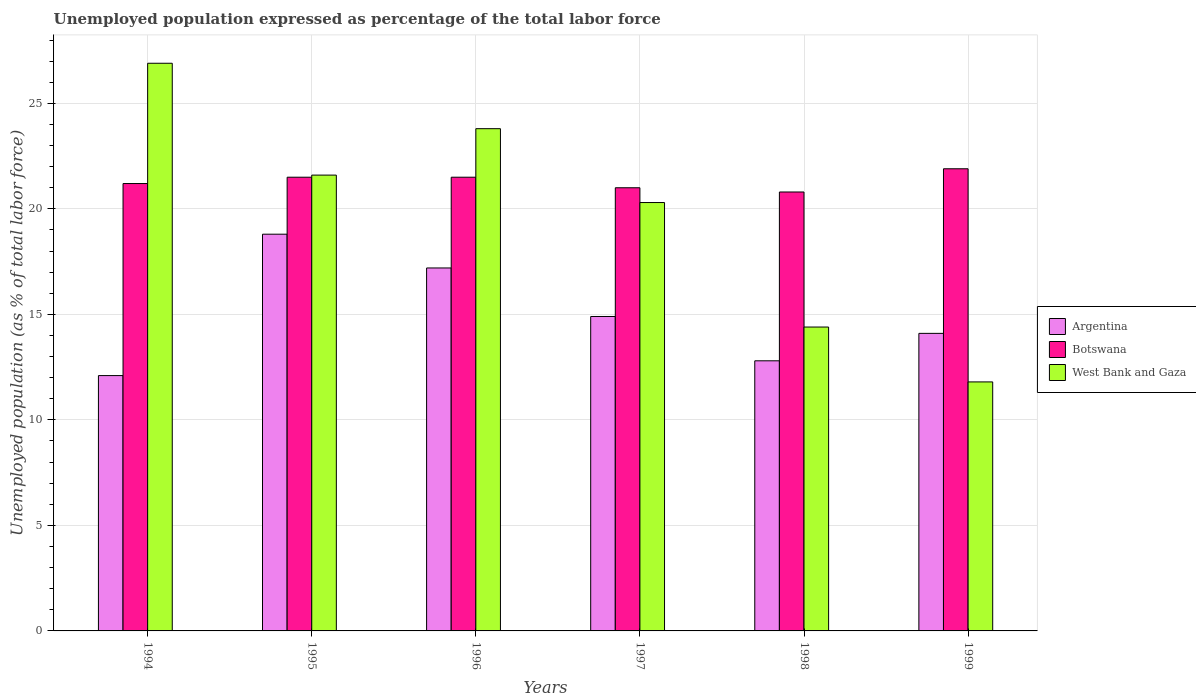How many different coloured bars are there?
Ensure brevity in your answer.  3. Are the number of bars per tick equal to the number of legend labels?
Make the answer very short. Yes. Are the number of bars on each tick of the X-axis equal?
Your answer should be very brief. Yes. How many bars are there on the 1st tick from the right?
Make the answer very short. 3. In how many cases, is the number of bars for a given year not equal to the number of legend labels?
Offer a very short reply. 0. What is the unemployment in in Argentina in 1996?
Your response must be concise. 17.2. Across all years, what is the maximum unemployment in in Botswana?
Make the answer very short. 21.9. Across all years, what is the minimum unemployment in in Botswana?
Offer a very short reply. 20.8. In which year was the unemployment in in Argentina maximum?
Make the answer very short. 1995. What is the total unemployment in in West Bank and Gaza in the graph?
Offer a terse response. 118.8. What is the difference between the unemployment in in Botswana in 1997 and the unemployment in in Argentina in 1994?
Provide a succinct answer. 8.9. What is the average unemployment in in West Bank and Gaza per year?
Keep it short and to the point. 19.8. In the year 1998, what is the difference between the unemployment in in West Bank and Gaza and unemployment in in Argentina?
Your answer should be very brief. 1.6. What is the ratio of the unemployment in in West Bank and Gaza in 1994 to that in 1996?
Make the answer very short. 1.13. What is the difference between the highest and the second highest unemployment in in Botswana?
Offer a terse response. 0.4. What is the difference between the highest and the lowest unemployment in in Argentina?
Your response must be concise. 6.7. In how many years, is the unemployment in in West Bank and Gaza greater than the average unemployment in in West Bank and Gaza taken over all years?
Your answer should be compact. 4. What does the 2nd bar from the left in 1995 represents?
Your answer should be very brief. Botswana. What does the 3rd bar from the right in 1996 represents?
Offer a terse response. Argentina. Is it the case that in every year, the sum of the unemployment in in West Bank and Gaza and unemployment in in Botswana is greater than the unemployment in in Argentina?
Make the answer very short. Yes. How many years are there in the graph?
Offer a terse response. 6. Does the graph contain any zero values?
Ensure brevity in your answer.  No. How many legend labels are there?
Keep it short and to the point. 3. What is the title of the graph?
Offer a very short reply. Unemployed population expressed as percentage of the total labor force. What is the label or title of the X-axis?
Your answer should be compact. Years. What is the label or title of the Y-axis?
Offer a terse response. Unemployed population (as % of total labor force). What is the Unemployed population (as % of total labor force) in Argentina in 1994?
Give a very brief answer. 12.1. What is the Unemployed population (as % of total labor force) in Botswana in 1994?
Your answer should be compact. 21.2. What is the Unemployed population (as % of total labor force) of West Bank and Gaza in 1994?
Make the answer very short. 26.9. What is the Unemployed population (as % of total labor force) in Argentina in 1995?
Provide a short and direct response. 18.8. What is the Unemployed population (as % of total labor force) in West Bank and Gaza in 1995?
Provide a short and direct response. 21.6. What is the Unemployed population (as % of total labor force) of Argentina in 1996?
Your response must be concise. 17.2. What is the Unemployed population (as % of total labor force) in Botswana in 1996?
Your response must be concise. 21.5. What is the Unemployed population (as % of total labor force) of West Bank and Gaza in 1996?
Provide a succinct answer. 23.8. What is the Unemployed population (as % of total labor force) in Argentina in 1997?
Make the answer very short. 14.9. What is the Unemployed population (as % of total labor force) in West Bank and Gaza in 1997?
Make the answer very short. 20.3. What is the Unemployed population (as % of total labor force) in Argentina in 1998?
Offer a very short reply. 12.8. What is the Unemployed population (as % of total labor force) of Botswana in 1998?
Your response must be concise. 20.8. What is the Unemployed population (as % of total labor force) in West Bank and Gaza in 1998?
Keep it short and to the point. 14.4. What is the Unemployed population (as % of total labor force) of Argentina in 1999?
Give a very brief answer. 14.1. What is the Unemployed population (as % of total labor force) in Botswana in 1999?
Provide a succinct answer. 21.9. What is the Unemployed population (as % of total labor force) in West Bank and Gaza in 1999?
Offer a terse response. 11.8. Across all years, what is the maximum Unemployed population (as % of total labor force) of Argentina?
Provide a short and direct response. 18.8. Across all years, what is the maximum Unemployed population (as % of total labor force) of Botswana?
Provide a succinct answer. 21.9. Across all years, what is the maximum Unemployed population (as % of total labor force) in West Bank and Gaza?
Your answer should be very brief. 26.9. Across all years, what is the minimum Unemployed population (as % of total labor force) of Argentina?
Offer a very short reply. 12.1. Across all years, what is the minimum Unemployed population (as % of total labor force) in Botswana?
Your answer should be compact. 20.8. Across all years, what is the minimum Unemployed population (as % of total labor force) of West Bank and Gaza?
Ensure brevity in your answer.  11.8. What is the total Unemployed population (as % of total labor force) of Argentina in the graph?
Your answer should be compact. 89.9. What is the total Unemployed population (as % of total labor force) of Botswana in the graph?
Provide a succinct answer. 127.9. What is the total Unemployed population (as % of total labor force) in West Bank and Gaza in the graph?
Ensure brevity in your answer.  118.8. What is the difference between the Unemployed population (as % of total labor force) of Argentina in 1994 and that in 1997?
Keep it short and to the point. -2.8. What is the difference between the Unemployed population (as % of total labor force) in Botswana in 1994 and that in 1997?
Ensure brevity in your answer.  0.2. What is the difference between the Unemployed population (as % of total labor force) of Argentina in 1994 and that in 1998?
Keep it short and to the point. -0.7. What is the difference between the Unemployed population (as % of total labor force) in Botswana in 1994 and that in 1999?
Give a very brief answer. -0.7. What is the difference between the Unemployed population (as % of total labor force) in West Bank and Gaza in 1994 and that in 1999?
Keep it short and to the point. 15.1. What is the difference between the Unemployed population (as % of total labor force) in Argentina in 1995 and that in 1996?
Provide a succinct answer. 1.6. What is the difference between the Unemployed population (as % of total labor force) of West Bank and Gaza in 1995 and that in 1996?
Your answer should be compact. -2.2. What is the difference between the Unemployed population (as % of total labor force) of Argentina in 1995 and that in 1997?
Give a very brief answer. 3.9. What is the difference between the Unemployed population (as % of total labor force) in Botswana in 1995 and that in 1997?
Provide a short and direct response. 0.5. What is the difference between the Unemployed population (as % of total labor force) in West Bank and Gaza in 1995 and that in 1997?
Offer a terse response. 1.3. What is the difference between the Unemployed population (as % of total labor force) in Argentina in 1995 and that in 1998?
Keep it short and to the point. 6. What is the difference between the Unemployed population (as % of total labor force) of Botswana in 1995 and that in 1998?
Your answer should be compact. 0.7. What is the difference between the Unemployed population (as % of total labor force) of West Bank and Gaza in 1995 and that in 1998?
Provide a short and direct response. 7.2. What is the difference between the Unemployed population (as % of total labor force) in West Bank and Gaza in 1995 and that in 1999?
Give a very brief answer. 9.8. What is the difference between the Unemployed population (as % of total labor force) in West Bank and Gaza in 1996 and that in 1997?
Offer a terse response. 3.5. What is the difference between the Unemployed population (as % of total labor force) of Argentina in 1996 and that in 1998?
Make the answer very short. 4.4. What is the difference between the Unemployed population (as % of total labor force) in Botswana in 1996 and that in 1998?
Your answer should be very brief. 0.7. What is the difference between the Unemployed population (as % of total labor force) in West Bank and Gaza in 1996 and that in 1998?
Your response must be concise. 9.4. What is the difference between the Unemployed population (as % of total labor force) in West Bank and Gaza in 1996 and that in 1999?
Make the answer very short. 12. What is the difference between the Unemployed population (as % of total labor force) in West Bank and Gaza in 1997 and that in 1998?
Offer a terse response. 5.9. What is the difference between the Unemployed population (as % of total labor force) of Argentina in 1997 and that in 1999?
Give a very brief answer. 0.8. What is the difference between the Unemployed population (as % of total labor force) in Botswana in 1997 and that in 1999?
Offer a terse response. -0.9. What is the difference between the Unemployed population (as % of total labor force) of West Bank and Gaza in 1998 and that in 1999?
Make the answer very short. 2.6. What is the difference between the Unemployed population (as % of total labor force) in Argentina in 1994 and the Unemployed population (as % of total labor force) in Botswana in 1995?
Provide a succinct answer. -9.4. What is the difference between the Unemployed population (as % of total labor force) of Botswana in 1994 and the Unemployed population (as % of total labor force) of West Bank and Gaza in 1995?
Provide a short and direct response. -0.4. What is the difference between the Unemployed population (as % of total labor force) of Argentina in 1994 and the Unemployed population (as % of total labor force) of West Bank and Gaza in 1996?
Your answer should be compact. -11.7. What is the difference between the Unemployed population (as % of total labor force) in Botswana in 1994 and the Unemployed population (as % of total labor force) in West Bank and Gaza in 1996?
Make the answer very short. -2.6. What is the difference between the Unemployed population (as % of total labor force) of Botswana in 1994 and the Unemployed population (as % of total labor force) of West Bank and Gaza in 1997?
Make the answer very short. 0.9. What is the difference between the Unemployed population (as % of total labor force) in Argentina in 1994 and the Unemployed population (as % of total labor force) in Botswana in 1998?
Ensure brevity in your answer.  -8.7. What is the difference between the Unemployed population (as % of total labor force) of Argentina in 1994 and the Unemployed population (as % of total labor force) of Botswana in 1999?
Your answer should be compact. -9.8. What is the difference between the Unemployed population (as % of total labor force) in Botswana in 1994 and the Unemployed population (as % of total labor force) in West Bank and Gaza in 1999?
Provide a short and direct response. 9.4. What is the difference between the Unemployed population (as % of total labor force) in Argentina in 1995 and the Unemployed population (as % of total labor force) in West Bank and Gaza in 1996?
Give a very brief answer. -5. What is the difference between the Unemployed population (as % of total labor force) in Argentina in 1995 and the Unemployed population (as % of total labor force) in Botswana in 1997?
Your response must be concise. -2.2. What is the difference between the Unemployed population (as % of total labor force) in Argentina in 1995 and the Unemployed population (as % of total labor force) in Botswana in 1998?
Provide a succinct answer. -2. What is the difference between the Unemployed population (as % of total labor force) in Botswana in 1995 and the Unemployed population (as % of total labor force) in West Bank and Gaza in 1998?
Your answer should be compact. 7.1. What is the difference between the Unemployed population (as % of total labor force) in Botswana in 1996 and the Unemployed population (as % of total labor force) in West Bank and Gaza in 1997?
Offer a very short reply. 1.2. What is the difference between the Unemployed population (as % of total labor force) of Argentina in 1996 and the Unemployed population (as % of total labor force) of Botswana in 1998?
Give a very brief answer. -3.6. What is the difference between the Unemployed population (as % of total labor force) of Argentina in 1996 and the Unemployed population (as % of total labor force) of West Bank and Gaza in 1998?
Make the answer very short. 2.8. What is the difference between the Unemployed population (as % of total labor force) in Argentina in 1996 and the Unemployed population (as % of total labor force) in Botswana in 1999?
Provide a succinct answer. -4.7. What is the difference between the Unemployed population (as % of total labor force) of Argentina in 1996 and the Unemployed population (as % of total labor force) of West Bank and Gaza in 1999?
Provide a succinct answer. 5.4. What is the difference between the Unemployed population (as % of total labor force) in Botswana in 1996 and the Unemployed population (as % of total labor force) in West Bank and Gaza in 1999?
Your answer should be very brief. 9.7. What is the difference between the Unemployed population (as % of total labor force) of Argentina in 1997 and the Unemployed population (as % of total labor force) of Botswana in 1998?
Your answer should be compact. -5.9. What is the difference between the Unemployed population (as % of total labor force) of Botswana in 1997 and the Unemployed population (as % of total labor force) of West Bank and Gaza in 1998?
Offer a terse response. 6.6. What is the difference between the Unemployed population (as % of total labor force) of Botswana in 1997 and the Unemployed population (as % of total labor force) of West Bank and Gaza in 1999?
Your response must be concise. 9.2. What is the difference between the Unemployed population (as % of total labor force) of Botswana in 1998 and the Unemployed population (as % of total labor force) of West Bank and Gaza in 1999?
Your answer should be compact. 9. What is the average Unemployed population (as % of total labor force) of Argentina per year?
Your answer should be compact. 14.98. What is the average Unemployed population (as % of total labor force) in Botswana per year?
Give a very brief answer. 21.32. What is the average Unemployed population (as % of total labor force) in West Bank and Gaza per year?
Provide a succinct answer. 19.8. In the year 1994, what is the difference between the Unemployed population (as % of total labor force) in Argentina and Unemployed population (as % of total labor force) in Botswana?
Make the answer very short. -9.1. In the year 1994, what is the difference between the Unemployed population (as % of total labor force) in Argentina and Unemployed population (as % of total labor force) in West Bank and Gaza?
Give a very brief answer. -14.8. In the year 1995, what is the difference between the Unemployed population (as % of total labor force) in Argentina and Unemployed population (as % of total labor force) in West Bank and Gaza?
Provide a short and direct response. -2.8. In the year 1995, what is the difference between the Unemployed population (as % of total labor force) in Botswana and Unemployed population (as % of total labor force) in West Bank and Gaza?
Your answer should be compact. -0.1. In the year 1996, what is the difference between the Unemployed population (as % of total labor force) in Argentina and Unemployed population (as % of total labor force) in West Bank and Gaza?
Your answer should be very brief. -6.6. In the year 1997, what is the difference between the Unemployed population (as % of total labor force) of Argentina and Unemployed population (as % of total labor force) of Botswana?
Your answer should be compact. -6.1. In the year 1997, what is the difference between the Unemployed population (as % of total labor force) in Argentina and Unemployed population (as % of total labor force) in West Bank and Gaza?
Provide a short and direct response. -5.4. In the year 1997, what is the difference between the Unemployed population (as % of total labor force) in Botswana and Unemployed population (as % of total labor force) in West Bank and Gaza?
Keep it short and to the point. 0.7. In the year 1998, what is the difference between the Unemployed population (as % of total labor force) in Botswana and Unemployed population (as % of total labor force) in West Bank and Gaza?
Your answer should be compact. 6.4. In the year 1999, what is the difference between the Unemployed population (as % of total labor force) of Argentina and Unemployed population (as % of total labor force) of Botswana?
Your response must be concise. -7.8. In the year 1999, what is the difference between the Unemployed population (as % of total labor force) of Botswana and Unemployed population (as % of total labor force) of West Bank and Gaza?
Provide a short and direct response. 10.1. What is the ratio of the Unemployed population (as % of total labor force) of Argentina in 1994 to that in 1995?
Provide a succinct answer. 0.64. What is the ratio of the Unemployed population (as % of total labor force) of Botswana in 1994 to that in 1995?
Your answer should be compact. 0.99. What is the ratio of the Unemployed population (as % of total labor force) of West Bank and Gaza in 1994 to that in 1995?
Your answer should be compact. 1.25. What is the ratio of the Unemployed population (as % of total labor force) of Argentina in 1994 to that in 1996?
Ensure brevity in your answer.  0.7. What is the ratio of the Unemployed population (as % of total labor force) in Botswana in 1994 to that in 1996?
Provide a short and direct response. 0.99. What is the ratio of the Unemployed population (as % of total labor force) in West Bank and Gaza in 1994 to that in 1996?
Your response must be concise. 1.13. What is the ratio of the Unemployed population (as % of total labor force) of Argentina in 1994 to that in 1997?
Give a very brief answer. 0.81. What is the ratio of the Unemployed population (as % of total labor force) of Botswana in 1994 to that in 1997?
Ensure brevity in your answer.  1.01. What is the ratio of the Unemployed population (as % of total labor force) in West Bank and Gaza in 1994 to that in 1997?
Provide a short and direct response. 1.33. What is the ratio of the Unemployed population (as % of total labor force) of Argentina in 1994 to that in 1998?
Your response must be concise. 0.95. What is the ratio of the Unemployed population (as % of total labor force) in Botswana in 1994 to that in 1998?
Your response must be concise. 1.02. What is the ratio of the Unemployed population (as % of total labor force) in West Bank and Gaza in 1994 to that in 1998?
Your answer should be very brief. 1.87. What is the ratio of the Unemployed population (as % of total labor force) in Argentina in 1994 to that in 1999?
Provide a succinct answer. 0.86. What is the ratio of the Unemployed population (as % of total labor force) of Botswana in 1994 to that in 1999?
Keep it short and to the point. 0.97. What is the ratio of the Unemployed population (as % of total labor force) in West Bank and Gaza in 1994 to that in 1999?
Make the answer very short. 2.28. What is the ratio of the Unemployed population (as % of total labor force) in Argentina in 1995 to that in 1996?
Your answer should be compact. 1.09. What is the ratio of the Unemployed population (as % of total labor force) in West Bank and Gaza in 1995 to that in 1996?
Your response must be concise. 0.91. What is the ratio of the Unemployed population (as % of total labor force) of Argentina in 1995 to that in 1997?
Offer a terse response. 1.26. What is the ratio of the Unemployed population (as % of total labor force) of Botswana in 1995 to that in 1997?
Your answer should be very brief. 1.02. What is the ratio of the Unemployed population (as % of total labor force) of West Bank and Gaza in 1995 to that in 1997?
Provide a succinct answer. 1.06. What is the ratio of the Unemployed population (as % of total labor force) in Argentina in 1995 to that in 1998?
Make the answer very short. 1.47. What is the ratio of the Unemployed population (as % of total labor force) in Botswana in 1995 to that in 1998?
Your answer should be very brief. 1.03. What is the ratio of the Unemployed population (as % of total labor force) in West Bank and Gaza in 1995 to that in 1998?
Make the answer very short. 1.5. What is the ratio of the Unemployed population (as % of total labor force) in Argentina in 1995 to that in 1999?
Ensure brevity in your answer.  1.33. What is the ratio of the Unemployed population (as % of total labor force) in Botswana in 1995 to that in 1999?
Offer a very short reply. 0.98. What is the ratio of the Unemployed population (as % of total labor force) of West Bank and Gaza in 1995 to that in 1999?
Make the answer very short. 1.83. What is the ratio of the Unemployed population (as % of total labor force) of Argentina in 1996 to that in 1997?
Provide a short and direct response. 1.15. What is the ratio of the Unemployed population (as % of total labor force) of Botswana in 1996 to that in 1997?
Make the answer very short. 1.02. What is the ratio of the Unemployed population (as % of total labor force) in West Bank and Gaza in 1996 to that in 1997?
Keep it short and to the point. 1.17. What is the ratio of the Unemployed population (as % of total labor force) of Argentina in 1996 to that in 1998?
Your answer should be very brief. 1.34. What is the ratio of the Unemployed population (as % of total labor force) of Botswana in 1996 to that in 1998?
Offer a terse response. 1.03. What is the ratio of the Unemployed population (as % of total labor force) in West Bank and Gaza in 1996 to that in 1998?
Ensure brevity in your answer.  1.65. What is the ratio of the Unemployed population (as % of total labor force) of Argentina in 1996 to that in 1999?
Provide a succinct answer. 1.22. What is the ratio of the Unemployed population (as % of total labor force) in Botswana in 1996 to that in 1999?
Offer a terse response. 0.98. What is the ratio of the Unemployed population (as % of total labor force) of West Bank and Gaza in 1996 to that in 1999?
Provide a short and direct response. 2.02. What is the ratio of the Unemployed population (as % of total labor force) in Argentina in 1997 to that in 1998?
Keep it short and to the point. 1.16. What is the ratio of the Unemployed population (as % of total labor force) in Botswana in 1997 to that in 1998?
Offer a very short reply. 1.01. What is the ratio of the Unemployed population (as % of total labor force) of West Bank and Gaza in 1997 to that in 1998?
Your answer should be very brief. 1.41. What is the ratio of the Unemployed population (as % of total labor force) of Argentina in 1997 to that in 1999?
Offer a terse response. 1.06. What is the ratio of the Unemployed population (as % of total labor force) in Botswana in 1997 to that in 1999?
Your answer should be very brief. 0.96. What is the ratio of the Unemployed population (as % of total labor force) of West Bank and Gaza in 1997 to that in 1999?
Your response must be concise. 1.72. What is the ratio of the Unemployed population (as % of total labor force) of Argentina in 1998 to that in 1999?
Offer a terse response. 0.91. What is the ratio of the Unemployed population (as % of total labor force) in Botswana in 1998 to that in 1999?
Give a very brief answer. 0.95. What is the ratio of the Unemployed population (as % of total labor force) in West Bank and Gaza in 1998 to that in 1999?
Ensure brevity in your answer.  1.22. What is the difference between the highest and the second highest Unemployed population (as % of total labor force) in Argentina?
Give a very brief answer. 1.6. What is the difference between the highest and the lowest Unemployed population (as % of total labor force) of Botswana?
Make the answer very short. 1.1. 